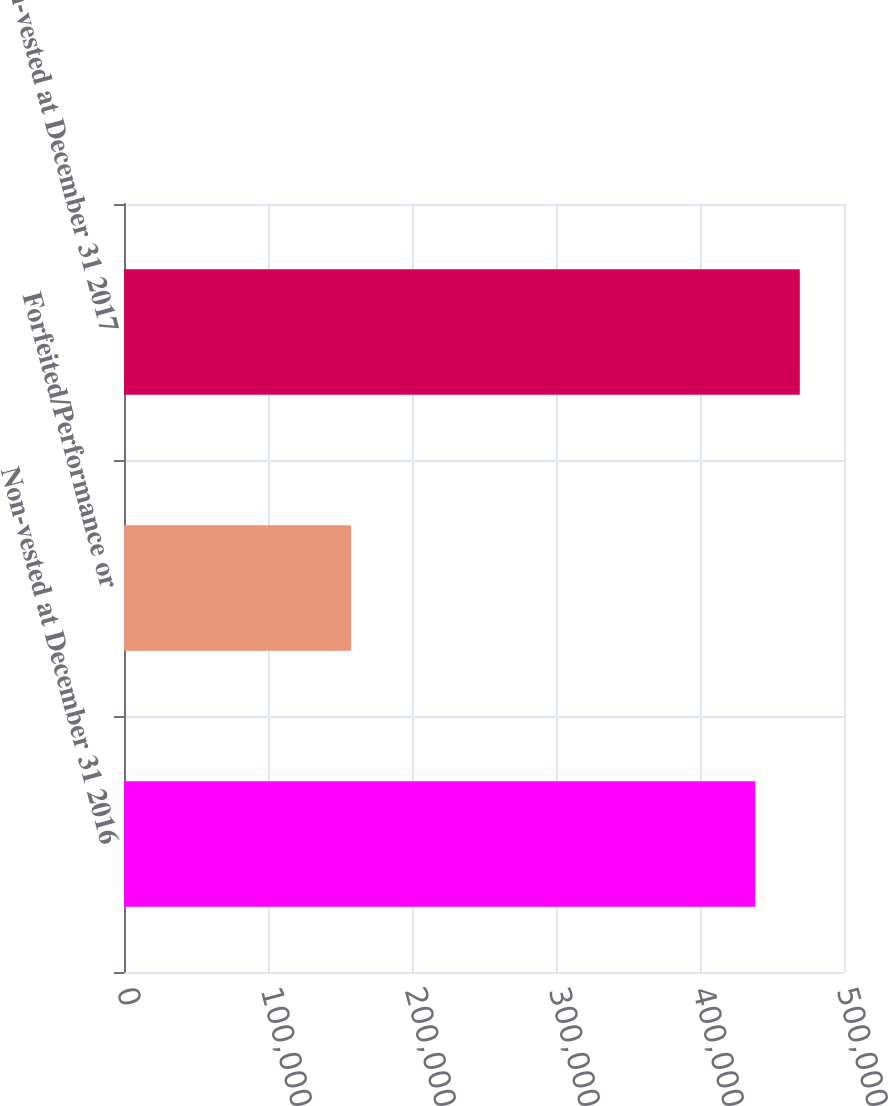Convert chart to OTSL. <chart><loc_0><loc_0><loc_500><loc_500><bar_chart><fcel>Non-vested at December 31 2016<fcel>Forfeited/Performance or<fcel>Non-vested at December 31 2017<nl><fcel>438302<fcel>157699<fcel>469313<nl></chart> 